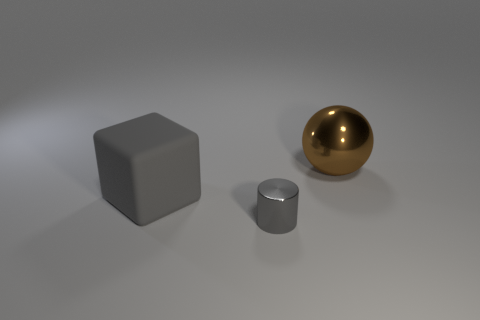Is there any other thing that has the same material as the big gray object?
Give a very brief answer. No. There is a cylinder that is the same color as the large matte cube; what size is it?
Make the answer very short. Small. The large thing in front of the shiny object behind the shiny thing in front of the brown ball is what shape?
Your response must be concise. Cube. How many small gray things have the same material as the ball?
Keep it short and to the point. 1. There is a shiny object in front of the large brown thing; what number of big brown metal balls are in front of it?
Provide a succinct answer. 0. There is a metallic object that is left of the big brown metallic object; is it the same color as the big thing that is right of the gray rubber cube?
Offer a terse response. No. What is the shape of the thing that is both behind the small gray shiny thing and in front of the large brown thing?
Offer a very short reply. Cube. Is there another large brown thing of the same shape as the big rubber object?
Your response must be concise. No. There is a thing that is the same size as the brown ball; what is its shape?
Keep it short and to the point. Cube. What material is the brown ball?
Offer a very short reply. Metal. 